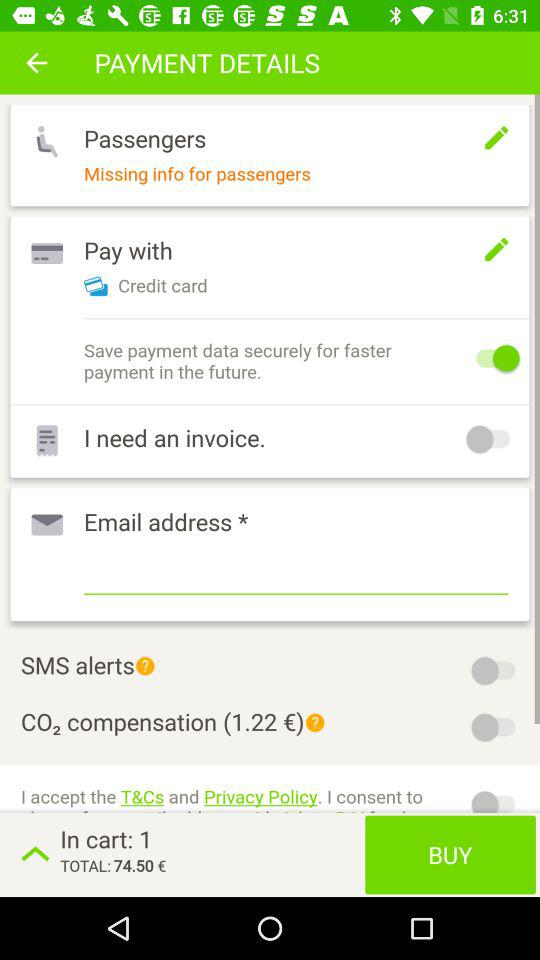What is the total price? The total price is €74.50. 